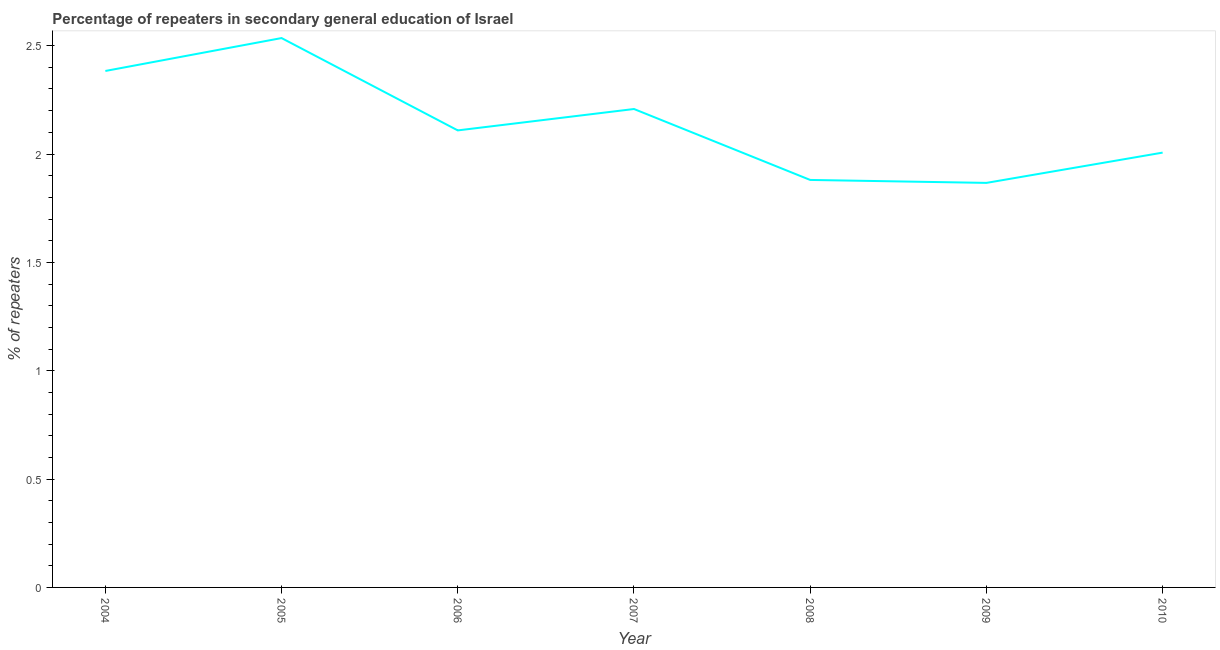What is the percentage of repeaters in 2008?
Your answer should be compact. 1.88. Across all years, what is the maximum percentage of repeaters?
Ensure brevity in your answer.  2.53. Across all years, what is the minimum percentage of repeaters?
Ensure brevity in your answer.  1.87. In which year was the percentage of repeaters maximum?
Keep it short and to the point. 2005. In which year was the percentage of repeaters minimum?
Provide a short and direct response. 2009. What is the sum of the percentage of repeaters?
Keep it short and to the point. 14.99. What is the difference between the percentage of repeaters in 2005 and 2010?
Offer a very short reply. 0.53. What is the average percentage of repeaters per year?
Your answer should be compact. 2.14. What is the median percentage of repeaters?
Provide a succinct answer. 2.11. In how many years, is the percentage of repeaters greater than 1.4 %?
Ensure brevity in your answer.  7. What is the ratio of the percentage of repeaters in 2008 to that in 2009?
Your answer should be very brief. 1.01. Is the percentage of repeaters in 2004 less than that in 2008?
Provide a short and direct response. No. Is the difference between the percentage of repeaters in 2008 and 2010 greater than the difference between any two years?
Ensure brevity in your answer.  No. What is the difference between the highest and the second highest percentage of repeaters?
Your response must be concise. 0.15. What is the difference between the highest and the lowest percentage of repeaters?
Your response must be concise. 0.67. In how many years, is the percentage of repeaters greater than the average percentage of repeaters taken over all years?
Your answer should be very brief. 3. How many lines are there?
Give a very brief answer. 1. How many years are there in the graph?
Your answer should be compact. 7. Are the values on the major ticks of Y-axis written in scientific E-notation?
Your response must be concise. No. Does the graph contain any zero values?
Provide a succinct answer. No. Does the graph contain grids?
Make the answer very short. No. What is the title of the graph?
Provide a short and direct response. Percentage of repeaters in secondary general education of Israel. What is the label or title of the Y-axis?
Keep it short and to the point. % of repeaters. What is the % of repeaters of 2004?
Give a very brief answer. 2.38. What is the % of repeaters in 2005?
Your response must be concise. 2.53. What is the % of repeaters in 2006?
Your answer should be very brief. 2.11. What is the % of repeaters of 2007?
Your answer should be compact. 2.21. What is the % of repeaters in 2008?
Your response must be concise. 1.88. What is the % of repeaters in 2009?
Offer a terse response. 1.87. What is the % of repeaters in 2010?
Make the answer very short. 2.01. What is the difference between the % of repeaters in 2004 and 2005?
Offer a terse response. -0.15. What is the difference between the % of repeaters in 2004 and 2006?
Your answer should be very brief. 0.27. What is the difference between the % of repeaters in 2004 and 2007?
Make the answer very short. 0.18. What is the difference between the % of repeaters in 2004 and 2008?
Make the answer very short. 0.5. What is the difference between the % of repeaters in 2004 and 2009?
Ensure brevity in your answer.  0.52. What is the difference between the % of repeaters in 2004 and 2010?
Your response must be concise. 0.38. What is the difference between the % of repeaters in 2005 and 2006?
Keep it short and to the point. 0.43. What is the difference between the % of repeaters in 2005 and 2007?
Offer a terse response. 0.33. What is the difference between the % of repeaters in 2005 and 2008?
Your answer should be very brief. 0.65. What is the difference between the % of repeaters in 2005 and 2009?
Your response must be concise. 0.67. What is the difference between the % of repeaters in 2005 and 2010?
Keep it short and to the point. 0.53. What is the difference between the % of repeaters in 2006 and 2007?
Offer a terse response. -0.1. What is the difference between the % of repeaters in 2006 and 2008?
Make the answer very short. 0.23. What is the difference between the % of repeaters in 2006 and 2009?
Provide a succinct answer. 0.24. What is the difference between the % of repeaters in 2006 and 2010?
Provide a succinct answer. 0.1. What is the difference between the % of repeaters in 2007 and 2008?
Offer a terse response. 0.33. What is the difference between the % of repeaters in 2007 and 2009?
Your response must be concise. 0.34. What is the difference between the % of repeaters in 2007 and 2010?
Offer a terse response. 0.2. What is the difference between the % of repeaters in 2008 and 2009?
Give a very brief answer. 0.01. What is the difference between the % of repeaters in 2008 and 2010?
Ensure brevity in your answer.  -0.13. What is the difference between the % of repeaters in 2009 and 2010?
Keep it short and to the point. -0.14. What is the ratio of the % of repeaters in 2004 to that in 2005?
Ensure brevity in your answer.  0.94. What is the ratio of the % of repeaters in 2004 to that in 2006?
Keep it short and to the point. 1.13. What is the ratio of the % of repeaters in 2004 to that in 2008?
Your answer should be very brief. 1.27. What is the ratio of the % of repeaters in 2004 to that in 2009?
Your response must be concise. 1.28. What is the ratio of the % of repeaters in 2004 to that in 2010?
Offer a very short reply. 1.19. What is the ratio of the % of repeaters in 2005 to that in 2006?
Provide a short and direct response. 1.2. What is the ratio of the % of repeaters in 2005 to that in 2007?
Offer a very short reply. 1.15. What is the ratio of the % of repeaters in 2005 to that in 2008?
Keep it short and to the point. 1.35. What is the ratio of the % of repeaters in 2005 to that in 2009?
Your answer should be very brief. 1.36. What is the ratio of the % of repeaters in 2005 to that in 2010?
Make the answer very short. 1.26. What is the ratio of the % of repeaters in 2006 to that in 2007?
Provide a succinct answer. 0.95. What is the ratio of the % of repeaters in 2006 to that in 2008?
Your answer should be very brief. 1.12. What is the ratio of the % of repeaters in 2006 to that in 2009?
Your answer should be compact. 1.13. What is the ratio of the % of repeaters in 2006 to that in 2010?
Ensure brevity in your answer.  1.05. What is the ratio of the % of repeaters in 2007 to that in 2008?
Your answer should be very brief. 1.17. What is the ratio of the % of repeaters in 2007 to that in 2009?
Your answer should be compact. 1.18. What is the ratio of the % of repeaters in 2008 to that in 2010?
Your response must be concise. 0.94. What is the ratio of the % of repeaters in 2009 to that in 2010?
Offer a very short reply. 0.93. 